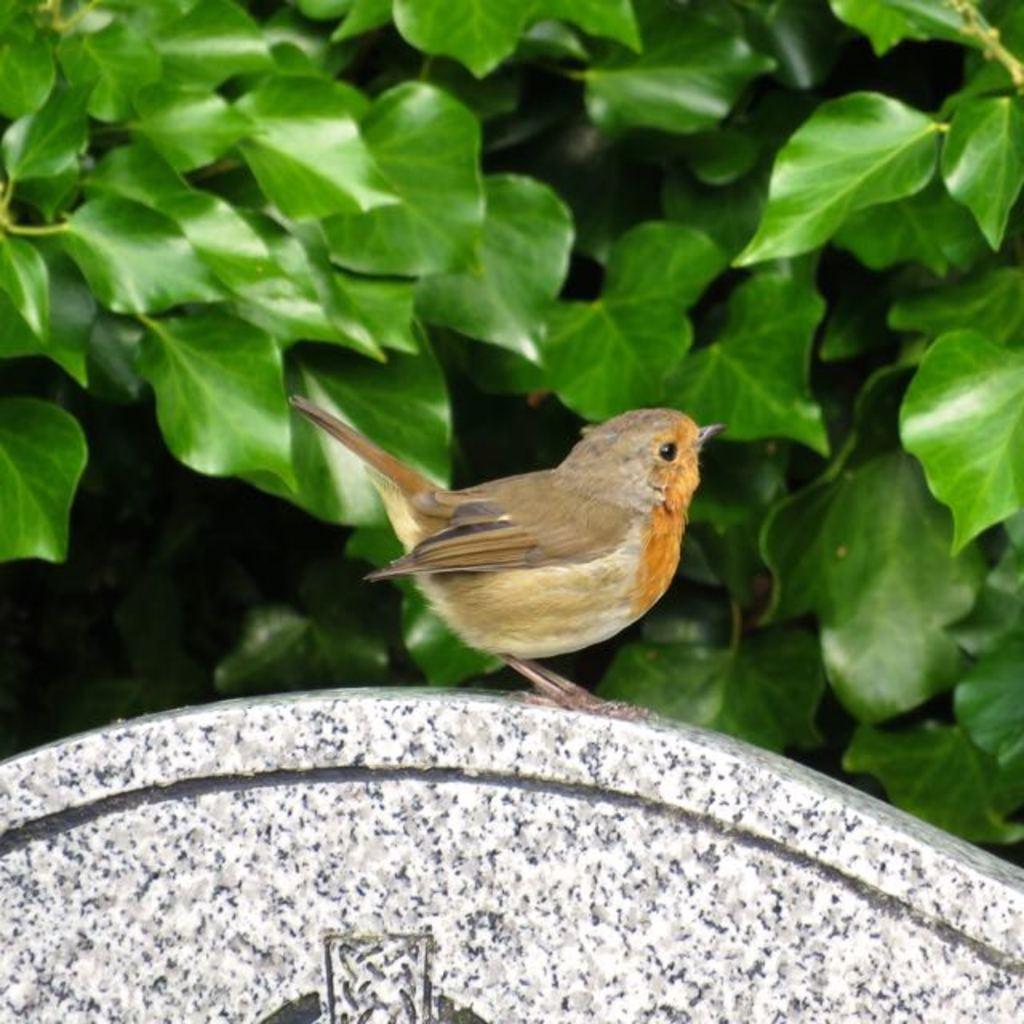Please provide a concise description of this image. A bird is present, behind that there are leaves. 